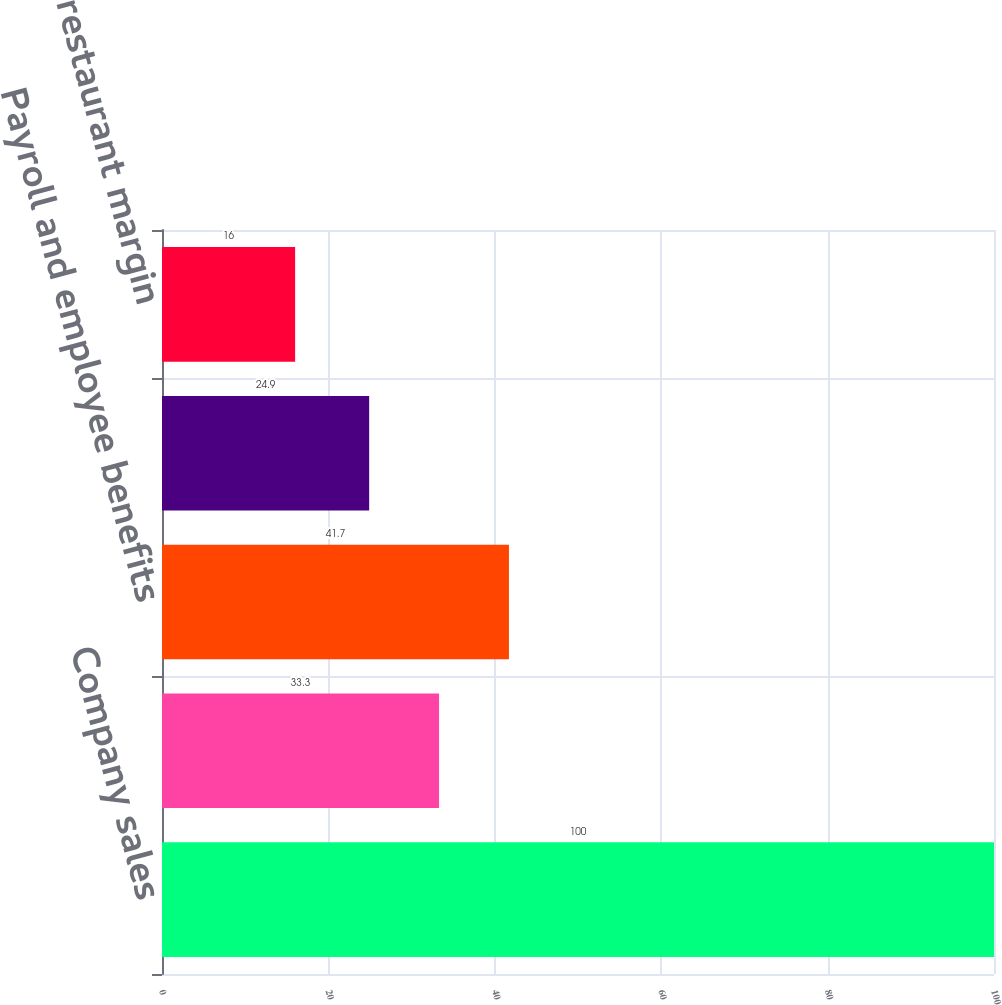Convert chart. <chart><loc_0><loc_0><loc_500><loc_500><bar_chart><fcel>Company sales<fcel>Food and paper<fcel>Payroll and employee benefits<fcel>Occupancy and other operating<fcel>Company restaurant margin<nl><fcel>100<fcel>33.3<fcel>41.7<fcel>24.9<fcel>16<nl></chart> 